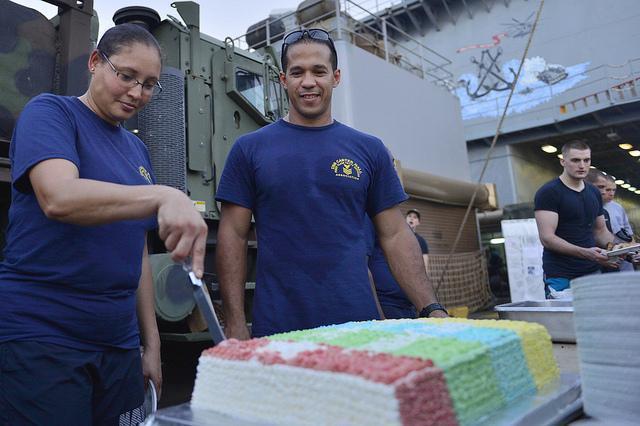How many people are in the picture?
Give a very brief answer. 4. How many trucks are there?
Give a very brief answer. 1. How many spoons are in this broccoli dish?
Give a very brief answer. 0. 